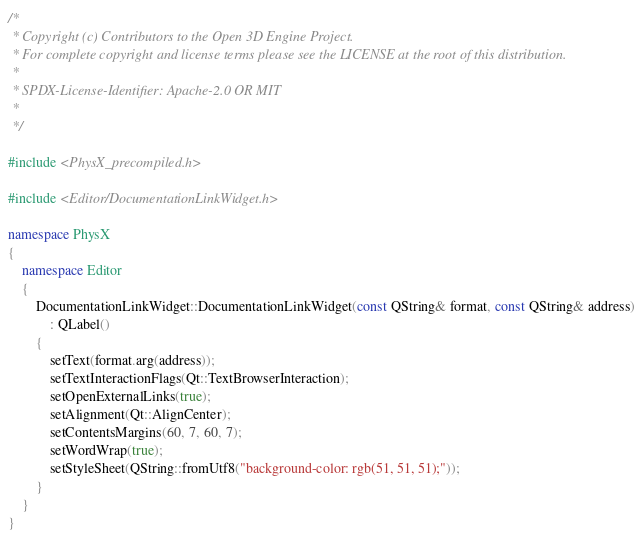Convert code to text. <code><loc_0><loc_0><loc_500><loc_500><_C++_>/*
 * Copyright (c) Contributors to the Open 3D Engine Project.
 * For complete copyright and license terms please see the LICENSE at the root of this distribution.
 *
 * SPDX-License-Identifier: Apache-2.0 OR MIT
 *
 */

#include <PhysX_precompiled.h>

#include <Editor/DocumentationLinkWidget.h>

namespace PhysX
{
    namespace Editor
    {
        DocumentationLinkWidget::DocumentationLinkWidget(const QString& format, const QString& address)
            : QLabel()
        {
            setText(format.arg(address));
            setTextInteractionFlags(Qt::TextBrowserInteraction);
            setOpenExternalLinks(true);
            setAlignment(Qt::AlignCenter);
            setContentsMargins(60, 7, 60, 7);
            setWordWrap(true);
            setStyleSheet(QString::fromUtf8("background-color: rgb(51, 51, 51);"));
        }
    }
}
</code> 